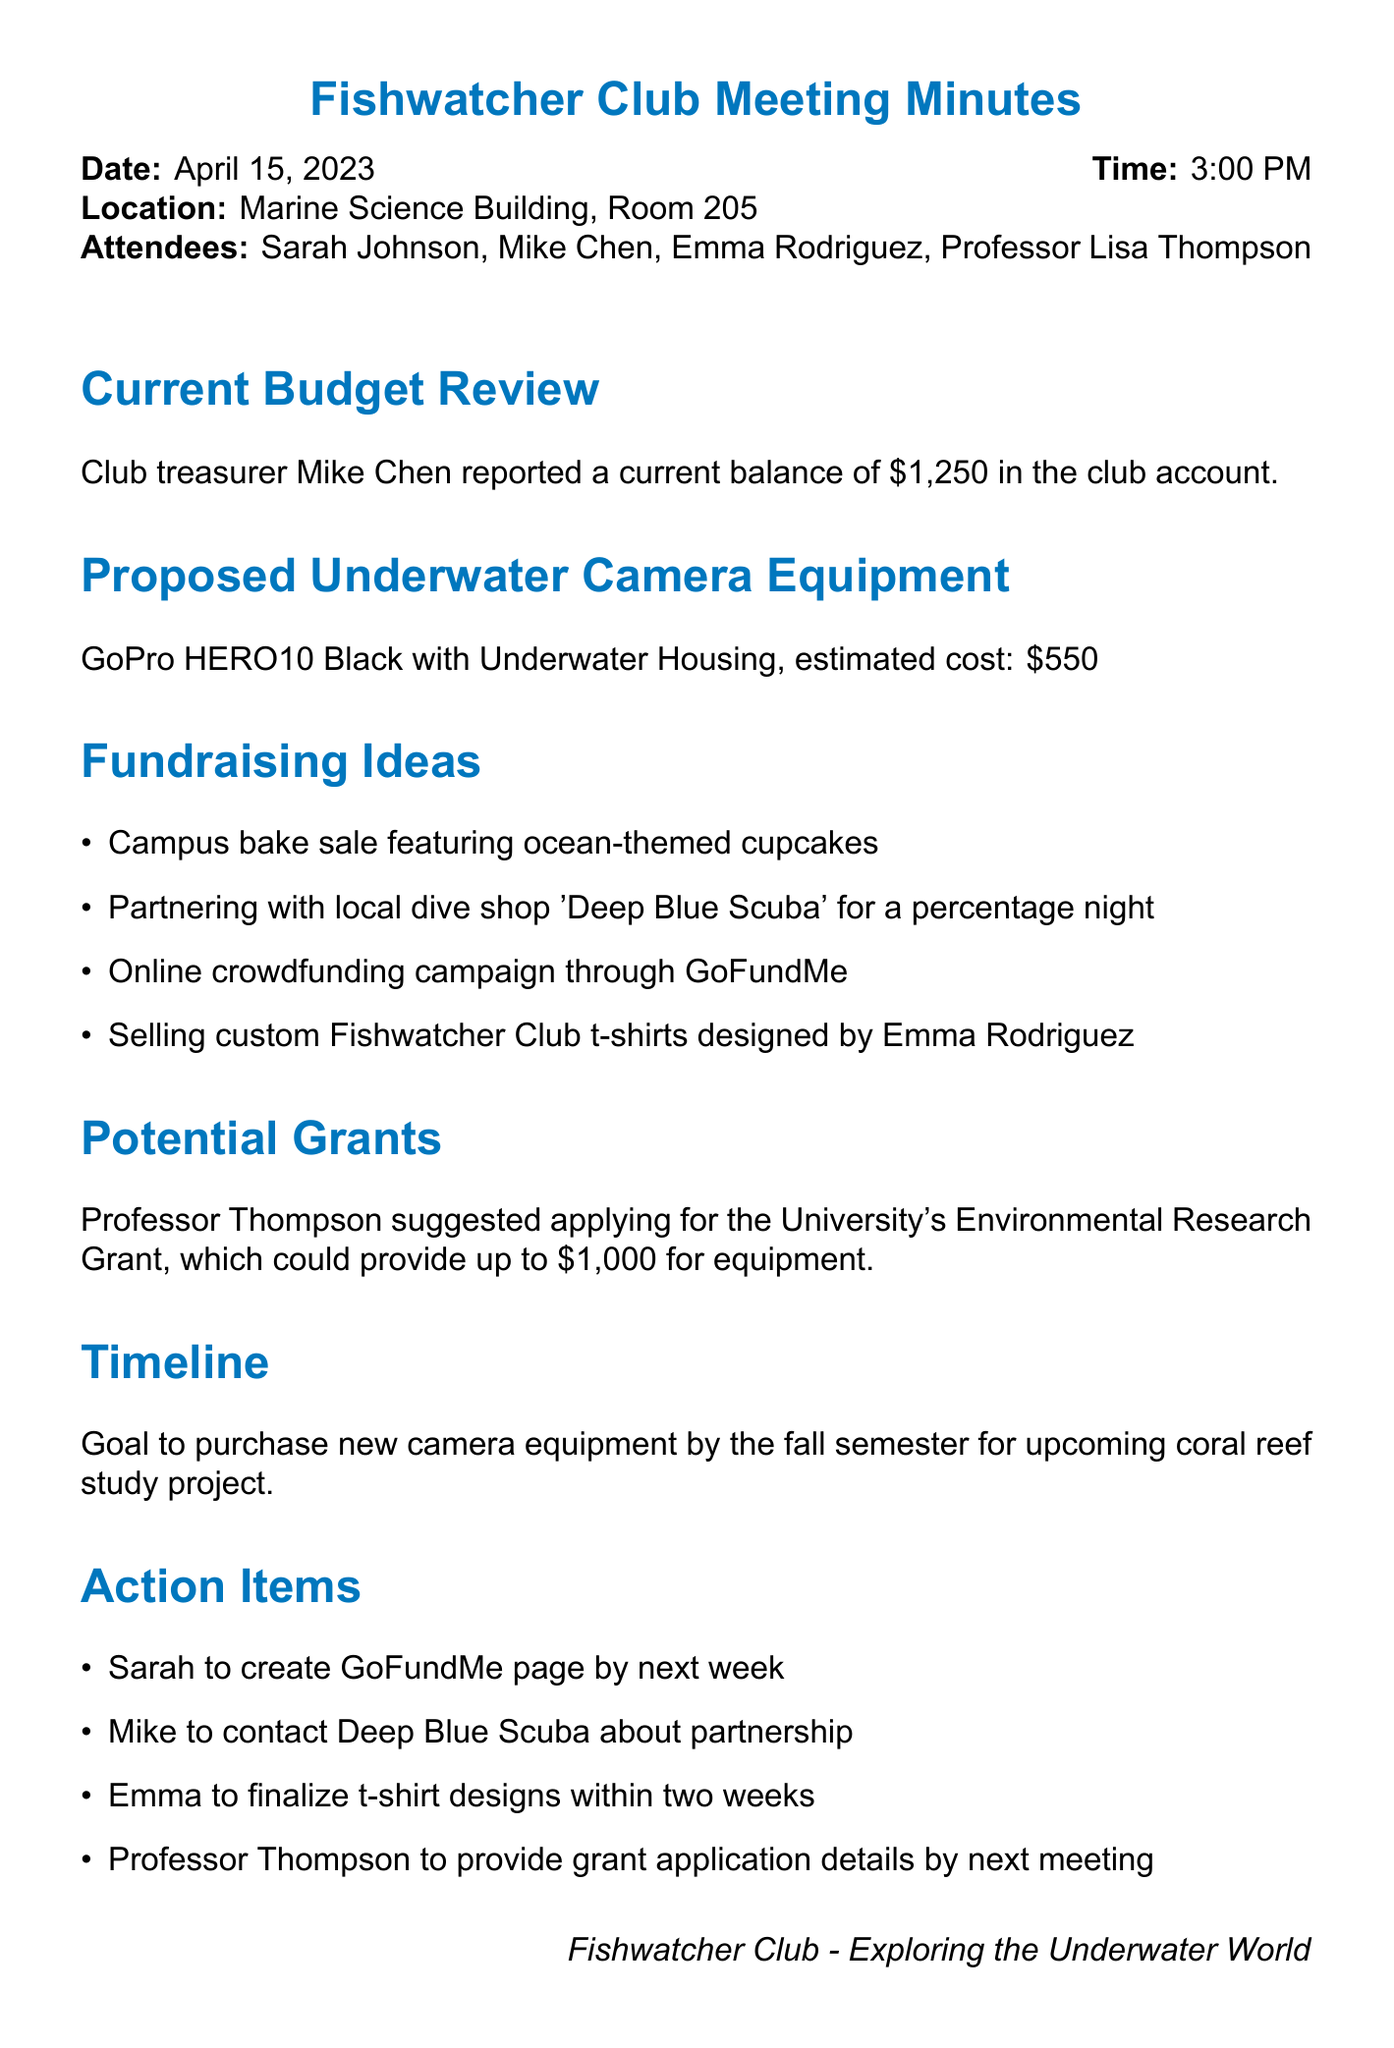what is the club's current budget balance? The treasurer reported a balance of $1,250 in the club account.
Answer: $1,250 what is the estimated cost of the proposed underwater camera equipment? The estimated cost of the GoPro HERO10 Black with Underwater Housing is mentioned in the document.
Answer: $550 which local dive shop is the club considering partnering with? The document lists a partnership with a specific dive shop for fundraising.
Answer: Deep Blue Scuba what is one of the fundraising ideas proposed by the club? The meeting minutes outline several fundraising ideas, one of which is a bake sale.
Answer: Campus bake sale featuring ocean-themed cupcakes who suggested applying for the University's Environmental Research Grant? The document attributes the suggestion for the grant application to a specific attendee.
Answer: Professor Thompson when is the goal to purchase new camera equipment? The document specifies a timeline for the purchase in relation to the fall semester.
Answer: by the fall semester who is responsible for creating the GoFundMe page? The action items list specifies who will take on the task of creating the crowdfunding page.
Answer: Sarah how many action items were listed in the meeting minutes? The document provides a specific count of tasks assigned to attendees.
Answer: 4 